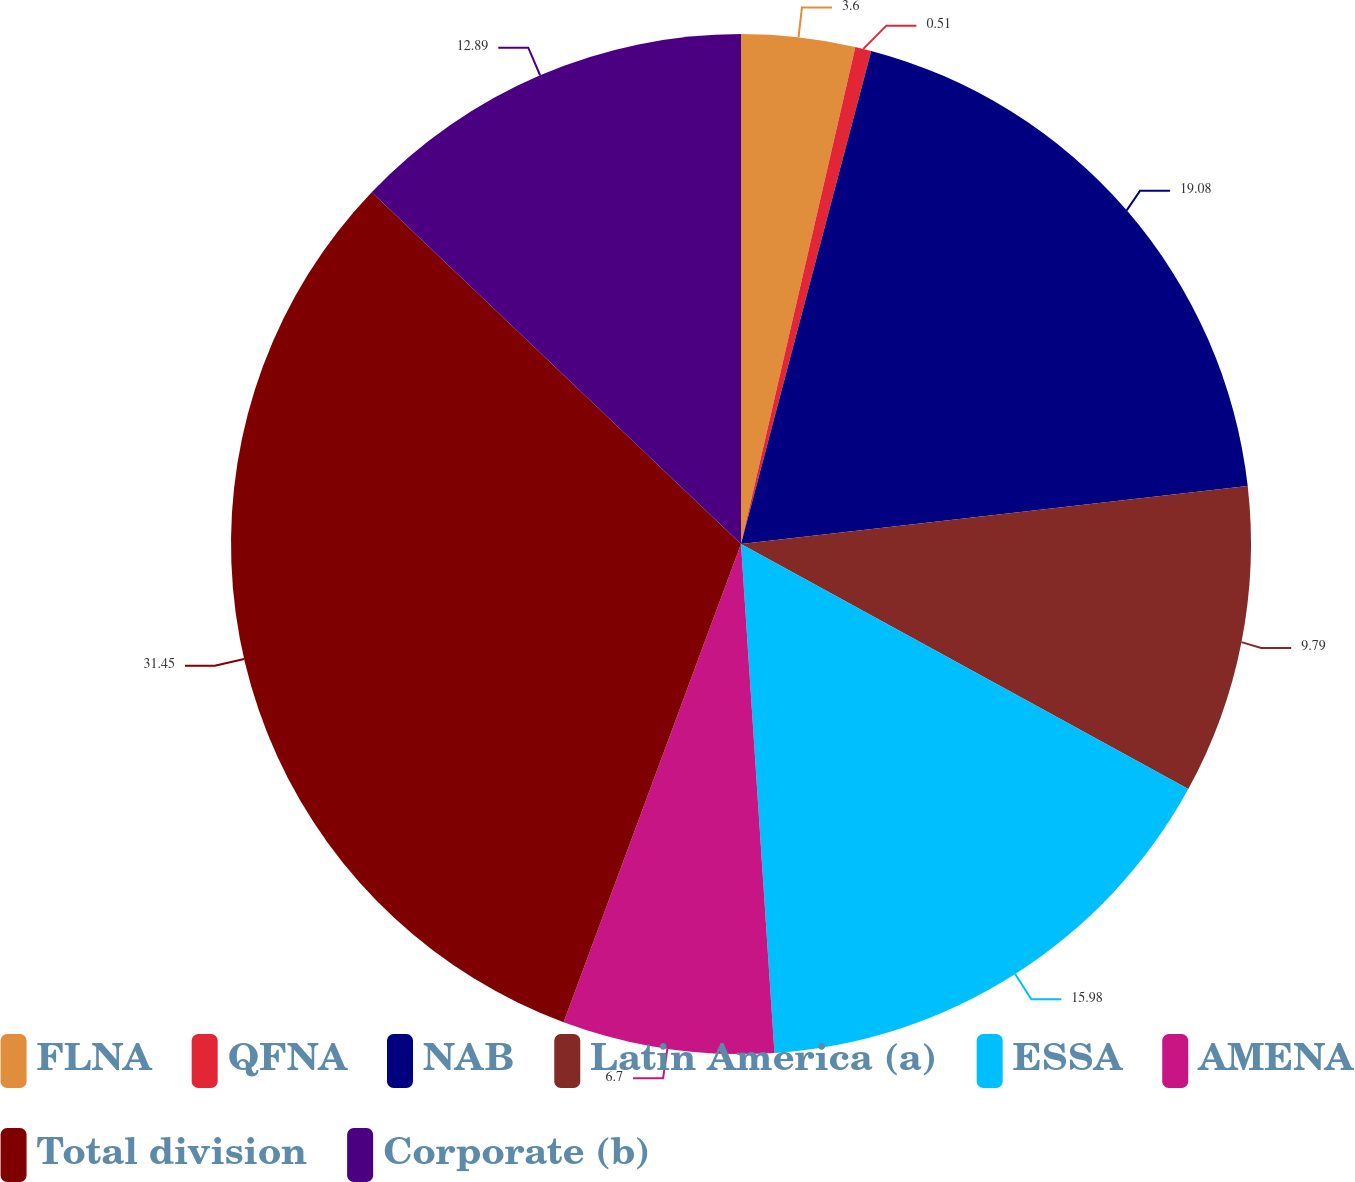Convert chart. <chart><loc_0><loc_0><loc_500><loc_500><pie_chart><fcel>FLNA<fcel>QFNA<fcel>NAB<fcel>Latin America (a)<fcel>ESSA<fcel>AMENA<fcel>Total division<fcel>Corporate (b)<nl><fcel>3.6%<fcel>0.51%<fcel>19.08%<fcel>9.79%<fcel>15.98%<fcel>6.7%<fcel>31.46%<fcel>12.89%<nl></chart> 